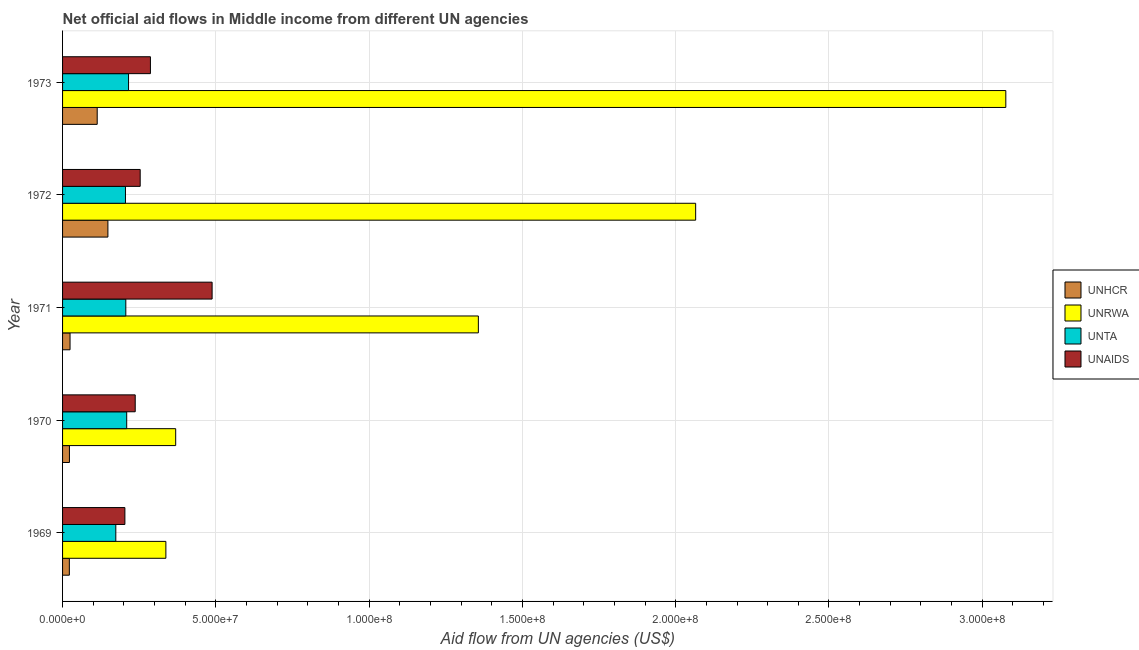How many different coloured bars are there?
Ensure brevity in your answer.  4. Are the number of bars per tick equal to the number of legend labels?
Make the answer very short. Yes. What is the label of the 5th group of bars from the top?
Provide a succinct answer. 1969. In how many cases, is the number of bars for a given year not equal to the number of legend labels?
Provide a succinct answer. 0. What is the amount of aid given by unta in 1969?
Provide a short and direct response. 1.74e+07. Across all years, what is the maximum amount of aid given by unta?
Your answer should be compact. 2.15e+07. Across all years, what is the minimum amount of aid given by unhcr?
Your answer should be compact. 2.21e+06. In which year was the amount of aid given by unaids maximum?
Ensure brevity in your answer.  1971. In which year was the amount of aid given by unrwa minimum?
Provide a short and direct response. 1969. What is the total amount of aid given by unrwa in the graph?
Provide a succinct answer. 7.20e+08. What is the difference between the amount of aid given by unhcr in 1970 and that in 1973?
Give a very brief answer. -9.06e+06. What is the difference between the amount of aid given by unaids in 1972 and the amount of aid given by unrwa in 1970?
Offer a terse response. -1.16e+07. What is the average amount of aid given by unta per year?
Offer a terse response. 2.02e+07. In the year 1971, what is the difference between the amount of aid given by unta and amount of aid given by unaids?
Give a very brief answer. -2.82e+07. What is the ratio of the amount of aid given by unhcr in 1970 to that in 1971?
Keep it short and to the point. 0.92. Is the difference between the amount of aid given by unaids in 1970 and 1971 greater than the difference between the amount of aid given by unta in 1970 and 1971?
Provide a short and direct response. No. What is the difference between the highest and the second highest amount of aid given by unrwa?
Give a very brief answer. 1.01e+08. What is the difference between the highest and the lowest amount of aid given by unta?
Your answer should be compact. 4.15e+06. In how many years, is the amount of aid given by unta greater than the average amount of aid given by unta taken over all years?
Provide a short and direct response. 4. Is it the case that in every year, the sum of the amount of aid given by unrwa and amount of aid given by unaids is greater than the sum of amount of aid given by unta and amount of aid given by unhcr?
Your answer should be compact. Yes. What does the 2nd bar from the top in 1969 represents?
Your response must be concise. UNTA. What does the 1st bar from the bottom in 1969 represents?
Provide a succinct answer. UNHCR. How many bars are there?
Keep it short and to the point. 20. How many years are there in the graph?
Your response must be concise. 5. Are the values on the major ticks of X-axis written in scientific E-notation?
Your answer should be compact. Yes. How many legend labels are there?
Offer a terse response. 4. How are the legend labels stacked?
Provide a short and direct response. Vertical. What is the title of the graph?
Offer a terse response. Net official aid flows in Middle income from different UN agencies. Does "Portugal" appear as one of the legend labels in the graph?
Provide a succinct answer. No. What is the label or title of the X-axis?
Provide a succinct answer. Aid flow from UN agencies (US$). What is the Aid flow from UN agencies (US$) of UNHCR in 1969?
Keep it short and to the point. 2.21e+06. What is the Aid flow from UN agencies (US$) of UNRWA in 1969?
Ensure brevity in your answer.  3.37e+07. What is the Aid flow from UN agencies (US$) of UNTA in 1969?
Offer a very short reply. 1.74e+07. What is the Aid flow from UN agencies (US$) of UNAIDS in 1969?
Your answer should be compact. 2.03e+07. What is the Aid flow from UN agencies (US$) of UNHCR in 1970?
Offer a very short reply. 2.24e+06. What is the Aid flow from UN agencies (US$) in UNRWA in 1970?
Your answer should be compact. 3.69e+07. What is the Aid flow from UN agencies (US$) in UNTA in 1970?
Make the answer very short. 2.09e+07. What is the Aid flow from UN agencies (US$) in UNAIDS in 1970?
Give a very brief answer. 2.37e+07. What is the Aid flow from UN agencies (US$) in UNHCR in 1971?
Offer a very short reply. 2.44e+06. What is the Aid flow from UN agencies (US$) in UNRWA in 1971?
Keep it short and to the point. 1.36e+08. What is the Aid flow from UN agencies (US$) of UNTA in 1971?
Offer a terse response. 2.06e+07. What is the Aid flow from UN agencies (US$) in UNAIDS in 1971?
Provide a succinct answer. 4.88e+07. What is the Aid flow from UN agencies (US$) in UNHCR in 1972?
Provide a short and direct response. 1.48e+07. What is the Aid flow from UN agencies (US$) in UNRWA in 1972?
Ensure brevity in your answer.  2.07e+08. What is the Aid flow from UN agencies (US$) of UNTA in 1972?
Provide a short and direct response. 2.05e+07. What is the Aid flow from UN agencies (US$) of UNAIDS in 1972?
Provide a succinct answer. 2.53e+07. What is the Aid flow from UN agencies (US$) in UNHCR in 1973?
Offer a very short reply. 1.13e+07. What is the Aid flow from UN agencies (US$) in UNRWA in 1973?
Provide a succinct answer. 3.08e+08. What is the Aid flow from UN agencies (US$) of UNTA in 1973?
Provide a short and direct response. 2.15e+07. What is the Aid flow from UN agencies (US$) of UNAIDS in 1973?
Make the answer very short. 2.87e+07. Across all years, what is the maximum Aid flow from UN agencies (US$) of UNHCR?
Offer a very short reply. 1.48e+07. Across all years, what is the maximum Aid flow from UN agencies (US$) in UNRWA?
Your answer should be compact. 3.08e+08. Across all years, what is the maximum Aid flow from UN agencies (US$) of UNTA?
Provide a succinct answer. 2.15e+07. Across all years, what is the maximum Aid flow from UN agencies (US$) of UNAIDS?
Offer a terse response. 4.88e+07. Across all years, what is the minimum Aid flow from UN agencies (US$) of UNHCR?
Your response must be concise. 2.21e+06. Across all years, what is the minimum Aid flow from UN agencies (US$) of UNRWA?
Offer a very short reply. 3.37e+07. Across all years, what is the minimum Aid flow from UN agencies (US$) in UNTA?
Provide a succinct answer. 1.74e+07. Across all years, what is the minimum Aid flow from UN agencies (US$) in UNAIDS?
Offer a terse response. 2.03e+07. What is the total Aid flow from UN agencies (US$) in UNHCR in the graph?
Offer a very short reply. 3.30e+07. What is the total Aid flow from UN agencies (US$) of UNRWA in the graph?
Keep it short and to the point. 7.20e+08. What is the total Aid flow from UN agencies (US$) in UNTA in the graph?
Your answer should be compact. 1.01e+08. What is the total Aid flow from UN agencies (US$) in UNAIDS in the graph?
Your response must be concise. 1.47e+08. What is the difference between the Aid flow from UN agencies (US$) of UNHCR in 1969 and that in 1970?
Make the answer very short. -3.00e+04. What is the difference between the Aid flow from UN agencies (US$) in UNRWA in 1969 and that in 1970?
Offer a very short reply. -3.20e+06. What is the difference between the Aid flow from UN agencies (US$) of UNTA in 1969 and that in 1970?
Your answer should be compact. -3.55e+06. What is the difference between the Aid flow from UN agencies (US$) in UNAIDS in 1969 and that in 1970?
Give a very brief answer. -3.37e+06. What is the difference between the Aid flow from UN agencies (US$) of UNRWA in 1969 and that in 1971?
Ensure brevity in your answer.  -1.02e+08. What is the difference between the Aid flow from UN agencies (US$) in UNTA in 1969 and that in 1971?
Offer a terse response. -3.26e+06. What is the difference between the Aid flow from UN agencies (US$) in UNAIDS in 1969 and that in 1971?
Give a very brief answer. -2.84e+07. What is the difference between the Aid flow from UN agencies (US$) of UNHCR in 1969 and that in 1972?
Ensure brevity in your answer.  -1.26e+07. What is the difference between the Aid flow from UN agencies (US$) in UNRWA in 1969 and that in 1972?
Your answer should be compact. -1.73e+08. What is the difference between the Aid flow from UN agencies (US$) in UNTA in 1969 and that in 1972?
Offer a very short reply. -3.15e+06. What is the difference between the Aid flow from UN agencies (US$) of UNAIDS in 1969 and that in 1972?
Your answer should be very brief. -4.99e+06. What is the difference between the Aid flow from UN agencies (US$) of UNHCR in 1969 and that in 1973?
Your answer should be compact. -9.09e+06. What is the difference between the Aid flow from UN agencies (US$) in UNRWA in 1969 and that in 1973?
Offer a terse response. -2.74e+08. What is the difference between the Aid flow from UN agencies (US$) of UNTA in 1969 and that in 1973?
Keep it short and to the point. -4.15e+06. What is the difference between the Aid flow from UN agencies (US$) of UNAIDS in 1969 and that in 1973?
Ensure brevity in your answer.  -8.33e+06. What is the difference between the Aid flow from UN agencies (US$) of UNHCR in 1970 and that in 1971?
Your answer should be very brief. -2.00e+05. What is the difference between the Aid flow from UN agencies (US$) of UNRWA in 1970 and that in 1971?
Offer a very short reply. -9.87e+07. What is the difference between the Aid flow from UN agencies (US$) of UNAIDS in 1970 and that in 1971?
Provide a succinct answer. -2.51e+07. What is the difference between the Aid flow from UN agencies (US$) of UNHCR in 1970 and that in 1972?
Your answer should be compact. -1.26e+07. What is the difference between the Aid flow from UN agencies (US$) of UNRWA in 1970 and that in 1972?
Keep it short and to the point. -1.70e+08. What is the difference between the Aid flow from UN agencies (US$) of UNTA in 1970 and that in 1972?
Offer a terse response. 4.00e+05. What is the difference between the Aid flow from UN agencies (US$) in UNAIDS in 1970 and that in 1972?
Make the answer very short. -1.62e+06. What is the difference between the Aid flow from UN agencies (US$) of UNHCR in 1970 and that in 1973?
Keep it short and to the point. -9.06e+06. What is the difference between the Aid flow from UN agencies (US$) in UNRWA in 1970 and that in 1973?
Provide a succinct answer. -2.71e+08. What is the difference between the Aid flow from UN agencies (US$) of UNTA in 1970 and that in 1973?
Your answer should be compact. -6.00e+05. What is the difference between the Aid flow from UN agencies (US$) of UNAIDS in 1970 and that in 1973?
Provide a succinct answer. -4.96e+06. What is the difference between the Aid flow from UN agencies (US$) in UNHCR in 1971 and that in 1972?
Your answer should be compact. -1.24e+07. What is the difference between the Aid flow from UN agencies (US$) of UNRWA in 1971 and that in 1972?
Give a very brief answer. -7.09e+07. What is the difference between the Aid flow from UN agencies (US$) of UNAIDS in 1971 and that in 1972?
Provide a succinct answer. 2.35e+07. What is the difference between the Aid flow from UN agencies (US$) of UNHCR in 1971 and that in 1973?
Provide a short and direct response. -8.86e+06. What is the difference between the Aid flow from UN agencies (US$) in UNRWA in 1971 and that in 1973?
Offer a very short reply. -1.72e+08. What is the difference between the Aid flow from UN agencies (US$) of UNTA in 1971 and that in 1973?
Your answer should be compact. -8.90e+05. What is the difference between the Aid flow from UN agencies (US$) in UNAIDS in 1971 and that in 1973?
Provide a short and direct response. 2.01e+07. What is the difference between the Aid flow from UN agencies (US$) of UNHCR in 1972 and that in 1973?
Give a very brief answer. 3.49e+06. What is the difference between the Aid flow from UN agencies (US$) of UNRWA in 1972 and that in 1973?
Provide a short and direct response. -1.01e+08. What is the difference between the Aid flow from UN agencies (US$) in UNTA in 1972 and that in 1973?
Offer a very short reply. -1.00e+06. What is the difference between the Aid flow from UN agencies (US$) in UNAIDS in 1972 and that in 1973?
Your response must be concise. -3.34e+06. What is the difference between the Aid flow from UN agencies (US$) of UNHCR in 1969 and the Aid flow from UN agencies (US$) of UNRWA in 1970?
Offer a terse response. -3.47e+07. What is the difference between the Aid flow from UN agencies (US$) of UNHCR in 1969 and the Aid flow from UN agencies (US$) of UNTA in 1970?
Your response must be concise. -1.87e+07. What is the difference between the Aid flow from UN agencies (US$) in UNHCR in 1969 and the Aid flow from UN agencies (US$) in UNAIDS in 1970?
Your answer should be compact. -2.15e+07. What is the difference between the Aid flow from UN agencies (US$) in UNRWA in 1969 and the Aid flow from UN agencies (US$) in UNTA in 1970?
Provide a short and direct response. 1.28e+07. What is the difference between the Aid flow from UN agencies (US$) in UNRWA in 1969 and the Aid flow from UN agencies (US$) in UNAIDS in 1970?
Your answer should be very brief. 1.00e+07. What is the difference between the Aid flow from UN agencies (US$) in UNTA in 1969 and the Aid flow from UN agencies (US$) in UNAIDS in 1970?
Your answer should be very brief. -6.33e+06. What is the difference between the Aid flow from UN agencies (US$) in UNHCR in 1969 and the Aid flow from UN agencies (US$) in UNRWA in 1971?
Give a very brief answer. -1.33e+08. What is the difference between the Aid flow from UN agencies (US$) in UNHCR in 1969 and the Aid flow from UN agencies (US$) in UNTA in 1971?
Offer a terse response. -1.84e+07. What is the difference between the Aid flow from UN agencies (US$) in UNHCR in 1969 and the Aid flow from UN agencies (US$) in UNAIDS in 1971?
Ensure brevity in your answer.  -4.66e+07. What is the difference between the Aid flow from UN agencies (US$) of UNRWA in 1969 and the Aid flow from UN agencies (US$) of UNTA in 1971?
Your answer should be very brief. 1.31e+07. What is the difference between the Aid flow from UN agencies (US$) of UNRWA in 1969 and the Aid flow from UN agencies (US$) of UNAIDS in 1971?
Offer a terse response. -1.51e+07. What is the difference between the Aid flow from UN agencies (US$) in UNTA in 1969 and the Aid flow from UN agencies (US$) in UNAIDS in 1971?
Offer a very short reply. -3.14e+07. What is the difference between the Aid flow from UN agencies (US$) of UNHCR in 1969 and the Aid flow from UN agencies (US$) of UNRWA in 1972?
Your answer should be compact. -2.04e+08. What is the difference between the Aid flow from UN agencies (US$) of UNHCR in 1969 and the Aid flow from UN agencies (US$) of UNTA in 1972?
Ensure brevity in your answer.  -1.83e+07. What is the difference between the Aid flow from UN agencies (US$) in UNHCR in 1969 and the Aid flow from UN agencies (US$) in UNAIDS in 1972?
Keep it short and to the point. -2.31e+07. What is the difference between the Aid flow from UN agencies (US$) of UNRWA in 1969 and the Aid flow from UN agencies (US$) of UNTA in 1972?
Make the answer very short. 1.32e+07. What is the difference between the Aid flow from UN agencies (US$) of UNRWA in 1969 and the Aid flow from UN agencies (US$) of UNAIDS in 1972?
Your answer should be compact. 8.38e+06. What is the difference between the Aid flow from UN agencies (US$) of UNTA in 1969 and the Aid flow from UN agencies (US$) of UNAIDS in 1972?
Your response must be concise. -7.95e+06. What is the difference between the Aid flow from UN agencies (US$) of UNHCR in 1969 and the Aid flow from UN agencies (US$) of UNRWA in 1973?
Keep it short and to the point. -3.05e+08. What is the difference between the Aid flow from UN agencies (US$) of UNHCR in 1969 and the Aid flow from UN agencies (US$) of UNTA in 1973?
Give a very brief answer. -1.93e+07. What is the difference between the Aid flow from UN agencies (US$) in UNHCR in 1969 and the Aid flow from UN agencies (US$) in UNAIDS in 1973?
Your answer should be compact. -2.64e+07. What is the difference between the Aid flow from UN agencies (US$) in UNRWA in 1969 and the Aid flow from UN agencies (US$) in UNTA in 1973?
Offer a very short reply. 1.22e+07. What is the difference between the Aid flow from UN agencies (US$) in UNRWA in 1969 and the Aid flow from UN agencies (US$) in UNAIDS in 1973?
Keep it short and to the point. 5.04e+06. What is the difference between the Aid flow from UN agencies (US$) of UNTA in 1969 and the Aid flow from UN agencies (US$) of UNAIDS in 1973?
Give a very brief answer. -1.13e+07. What is the difference between the Aid flow from UN agencies (US$) of UNHCR in 1970 and the Aid flow from UN agencies (US$) of UNRWA in 1971?
Ensure brevity in your answer.  -1.33e+08. What is the difference between the Aid flow from UN agencies (US$) of UNHCR in 1970 and the Aid flow from UN agencies (US$) of UNTA in 1971?
Your response must be concise. -1.84e+07. What is the difference between the Aid flow from UN agencies (US$) of UNHCR in 1970 and the Aid flow from UN agencies (US$) of UNAIDS in 1971?
Make the answer very short. -4.65e+07. What is the difference between the Aid flow from UN agencies (US$) in UNRWA in 1970 and the Aid flow from UN agencies (US$) in UNTA in 1971?
Make the answer very short. 1.63e+07. What is the difference between the Aid flow from UN agencies (US$) in UNRWA in 1970 and the Aid flow from UN agencies (US$) in UNAIDS in 1971?
Offer a very short reply. -1.19e+07. What is the difference between the Aid flow from UN agencies (US$) of UNTA in 1970 and the Aid flow from UN agencies (US$) of UNAIDS in 1971?
Provide a succinct answer. -2.79e+07. What is the difference between the Aid flow from UN agencies (US$) of UNHCR in 1970 and the Aid flow from UN agencies (US$) of UNRWA in 1972?
Offer a terse response. -2.04e+08. What is the difference between the Aid flow from UN agencies (US$) of UNHCR in 1970 and the Aid flow from UN agencies (US$) of UNTA in 1972?
Your response must be concise. -1.83e+07. What is the difference between the Aid flow from UN agencies (US$) in UNHCR in 1970 and the Aid flow from UN agencies (US$) in UNAIDS in 1972?
Offer a terse response. -2.31e+07. What is the difference between the Aid flow from UN agencies (US$) in UNRWA in 1970 and the Aid flow from UN agencies (US$) in UNTA in 1972?
Give a very brief answer. 1.64e+07. What is the difference between the Aid flow from UN agencies (US$) of UNRWA in 1970 and the Aid flow from UN agencies (US$) of UNAIDS in 1972?
Your answer should be compact. 1.16e+07. What is the difference between the Aid flow from UN agencies (US$) in UNTA in 1970 and the Aid flow from UN agencies (US$) in UNAIDS in 1972?
Your response must be concise. -4.40e+06. What is the difference between the Aid flow from UN agencies (US$) of UNHCR in 1970 and the Aid flow from UN agencies (US$) of UNRWA in 1973?
Your answer should be very brief. -3.05e+08. What is the difference between the Aid flow from UN agencies (US$) in UNHCR in 1970 and the Aid flow from UN agencies (US$) in UNTA in 1973?
Your response must be concise. -1.93e+07. What is the difference between the Aid flow from UN agencies (US$) in UNHCR in 1970 and the Aid flow from UN agencies (US$) in UNAIDS in 1973?
Offer a terse response. -2.64e+07. What is the difference between the Aid flow from UN agencies (US$) in UNRWA in 1970 and the Aid flow from UN agencies (US$) in UNTA in 1973?
Offer a terse response. 1.54e+07. What is the difference between the Aid flow from UN agencies (US$) of UNRWA in 1970 and the Aid flow from UN agencies (US$) of UNAIDS in 1973?
Give a very brief answer. 8.24e+06. What is the difference between the Aid flow from UN agencies (US$) of UNTA in 1970 and the Aid flow from UN agencies (US$) of UNAIDS in 1973?
Your answer should be compact. -7.74e+06. What is the difference between the Aid flow from UN agencies (US$) in UNHCR in 1971 and the Aid flow from UN agencies (US$) in UNRWA in 1972?
Your answer should be very brief. -2.04e+08. What is the difference between the Aid flow from UN agencies (US$) in UNHCR in 1971 and the Aid flow from UN agencies (US$) in UNTA in 1972?
Provide a succinct answer. -1.81e+07. What is the difference between the Aid flow from UN agencies (US$) in UNHCR in 1971 and the Aid flow from UN agencies (US$) in UNAIDS in 1972?
Provide a short and direct response. -2.29e+07. What is the difference between the Aid flow from UN agencies (US$) in UNRWA in 1971 and the Aid flow from UN agencies (US$) in UNTA in 1972?
Ensure brevity in your answer.  1.15e+08. What is the difference between the Aid flow from UN agencies (US$) in UNRWA in 1971 and the Aid flow from UN agencies (US$) in UNAIDS in 1972?
Give a very brief answer. 1.10e+08. What is the difference between the Aid flow from UN agencies (US$) in UNTA in 1971 and the Aid flow from UN agencies (US$) in UNAIDS in 1972?
Make the answer very short. -4.69e+06. What is the difference between the Aid flow from UN agencies (US$) in UNHCR in 1971 and the Aid flow from UN agencies (US$) in UNRWA in 1973?
Your answer should be compact. -3.05e+08. What is the difference between the Aid flow from UN agencies (US$) of UNHCR in 1971 and the Aid flow from UN agencies (US$) of UNTA in 1973?
Make the answer very short. -1.91e+07. What is the difference between the Aid flow from UN agencies (US$) in UNHCR in 1971 and the Aid flow from UN agencies (US$) in UNAIDS in 1973?
Provide a short and direct response. -2.62e+07. What is the difference between the Aid flow from UN agencies (US$) in UNRWA in 1971 and the Aid flow from UN agencies (US$) in UNTA in 1973?
Offer a terse response. 1.14e+08. What is the difference between the Aid flow from UN agencies (US$) of UNRWA in 1971 and the Aid flow from UN agencies (US$) of UNAIDS in 1973?
Keep it short and to the point. 1.07e+08. What is the difference between the Aid flow from UN agencies (US$) of UNTA in 1971 and the Aid flow from UN agencies (US$) of UNAIDS in 1973?
Ensure brevity in your answer.  -8.03e+06. What is the difference between the Aid flow from UN agencies (US$) in UNHCR in 1972 and the Aid flow from UN agencies (US$) in UNRWA in 1973?
Offer a very short reply. -2.93e+08. What is the difference between the Aid flow from UN agencies (US$) of UNHCR in 1972 and the Aid flow from UN agencies (US$) of UNTA in 1973?
Your answer should be very brief. -6.73e+06. What is the difference between the Aid flow from UN agencies (US$) of UNHCR in 1972 and the Aid flow from UN agencies (US$) of UNAIDS in 1973?
Give a very brief answer. -1.39e+07. What is the difference between the Aid flow from UN agencies (US$) of UNRWA in 1972 and the Aid flow from UN agencies (US$) of UNTA in 1973?
Keep it short and to the point. 1.85e+08. What is the difference between the Aid flow from UN agencies (US$) in UNRWA in 1972 and the Aid flow from UN agencies (US$) in UNAIDS in 1973?
Ensure brevity in your answer.  1.78e+08. What is the difference between the Aid flow from UN agencies (US$) of UNTA in 1972 and the Aid flow from UN agencies (US$) of UNAIDS in 1973?
Give a very brief answer. -8.14e+06. What is the average Aid flow from UN agencies (US$) in UNHCR per year?
Keep it short and to the point. 6.60e+06. What is the average Aid flow from UN agencies (US$) in UNRWA per year?
Make the answer very short. 1.44e+08. What is the average Aid flow from UN agencies (US$) of UNTA per year?
Make the answer very short. 2.02e+07. What is the average Aid flow from UN agencies (US$) of UNAIDS per year?
Provide a succinct answer. 2.94e+07. In the year 1969, what is the difference between the Aid flow from UN agencies (US$) in UNHCR and Aid flow from UN agencies (US$) in UNRWA?
Offer a very short reply. -3.15e+07. In the year 1969, what is the difference between the Aid flow from UN agencies (US$) in UNHCR and Aid flow from UN agencies (US$) in UNTA?
Offer a very short reply. -1.52e+07. In the year 1969, what is the difference between the Aid flow from UN agencies (US$) of UNHCR and Aid flow from UN agencies (US$) of UNAIDS?
Ensure brevity in your answer.  -1.81e+07. In the year 1969, what is the difference between the Aid flow from UN agencies (US$) of UNRWA and Aid flow from UN agencies (US$) of UNTA?
Ensure brevity in your answer.  1.63e+07. In the year 1969, what is the difference between the Aid flow from UN agencies (US$) in UNRWA and Aid flow from UN agencies (US$) in UNAIDS?
Your answer should be compact. 1.34e+07. In the year 1969, what is the difference between the Aid flow from UN agencies (US$) of UNTA and Aid flow from UN agencies (US$) of UNAIDS?
Your response must be concise. -2.96e+06. In the year 1970, what is the difference between the Aid flow from UN agencies (US$) of UNHCR and Aid flow from UN agencies (US$) of UNRWA?
Make the answer very short. -3.47e+07. In the year 1970, what is the difference between the Aid flow from UN agencies (US$) of UNHCR and Aid flow from UN agencies (US$) of UNTA?
Keep it short and to the point. -1.87e+07. In the year 1970, what is the difference between the Aid flow from UN agencies (US$) in UNHCR and Aid flow from UN agencies (US$) in UNAIDS?
Your answer should be very brief. -2.15e+07. In the year 1970, what is the difference between the Aid flow from UN agencies (US$) in UNRWA and Aid flow from UN agencies (US$) in UNTA?
Provide a succinct answer. 1.60e+07. In the year 1970, what is the difference between the Aid flow from UN agencies (US$) in UNRWA and Aid flow from UN agencies (US$) in UNAIDS?
Your answer should be very brief. 1.32e+07. In the year 1970, what is the difference between the Aid flow from UN agencies (US$) in UNTA and Aid flow from UN agencies (US$) in UNAIDS?
Offer a terse response. -2.78e+06. In the year 1971, what is the difference between the Aid flow from UN agencies (US$) of UNHCR and Aid flow from UN agencies (US$) of UNRWA?
Ensure brevity in your answer.  -1.33e+08. In the year 1971, what is the difference between the Aid flow from UN agencies (US$) of UNHCR and Aid flow from UN agencies (US$) of UNTA?
Give a very brief answer. -1.82e+07. In the year 1971, what is the difference between the Aid flow from UN agencies (US$) in UNHCR and Aid flow from UN agencies (US$) in UNAIDS?
Ensure brevity in your answer.  -4.63e+07. In the year 1971, what is the difference between the Aid flow from UN agencies (US$) of UNRWA and Aid flow from UN agencies (US$) of UNTA?
Your answer should be compact. 1.15e+08. In the year 1971, what is the difference between the Aid flow from UN agencies (US$) of UNRWA and Aid flow from UN agencies (US$) of UNAIDS?
Offer a terse response. 8.68e+07. In the year 1971, what is the difference between the Aid flow from UN agencies (US$) in UNTA and Aid flow from UN agencies (US$) in UNAIDS?
Offer a terse response. -2.82e+07. In the year 1972, what is the difference between the Aid flow from UN agencies (US$) in UNHCR and Aid flow from UN agencies (US$) in UNRWA?
Ensure brevity in your answer.  -1.92e+08. In the year 1972, what is the difference between the Aid flow from UN agencies (US$) in UNHCR and Aid flow from UN agencies (US$) in UNTA?
Your answer should be compact. -5.73e+06. In the year 1972, what is the difference between the Aid flow from UN agencies (US$) of UNHCR and Aid flow from UN agencies (US$) of UNAIDS?
Provide a succinct answer. -1.05e+07. In the year 1972, what is the difference between the Aid flow from UN agencies (US$) of UNRWA and Aid flow from UN agencies (US$) of UNTA?
Provide a succinct answer. 1.86e+08. In the year 1972, what is the difference between the Aid flow from UN agencies (US$) of UNRWA and Aid flow from UN agencies (US$) of UNAIDS?
Give a very brief answer. 1.81e+08. In the year 1972, what is the difference between the Aid flow from UN agencies (US$) in UNTA and Aid flow from UN agencies (US$) in UNAIDS?
Offer a very short reply. -4.80e+06. In the year 1973, what is the difference between the Aid flow from UN agencies (US$) of UNHCR and Aid flow from UN agencies (US$) of UNRWA?
Your answer should be compact. -2.96e+08. In the year 1973, what is the difference between the Aid flow from UN agencies (US$) in UNHCR and Aid flow from UN agencies (US$) in UNTA?
Give a very brief answer. -1.02e+07. In the year 1973, what is the difference between the Aid flow from UN agencies (US$) of UNHCR and Aid flow from UN agencies (US$) of UNAIDS?
Your answer should be very brief. -1.74e+07. In the year 1973, what is the difference between the Aid flow from UN agencies (US$) in UNRWA and Aid flow from UN agencies (US$) in UNTA?
Your response must be concise. 2.86e+08. In the year 1973, what is the difference between the Aid flow from UN agencies (US$) of UNRWA and Aid flow from UN agencies (US$) of UNAIDS?
Offer a terse response. 2.79e+08. In the year 1973, what is the difference between the Aid flow from UN agencies (US$) in UNTA and Aid flow from UN agencies (US$) in UNAIDS?
Give a very brief answer. -7.14e+06. What is the ratio of the Aid flow from UN agencies (US$) in UNHCR in 1969 to that in 1970?
Your answer should be compact. 0.99. What is the ratio of the Aid flow from UN agencies (US$) in UNRWA in 1969 to that in 1970?
Give a very brief answer. 0.91. What is the ratio of the Aid flow from UN agencies (US$) of UNTA in 1969 to that in 1970?
Ensure brevity in your answer.  0.83. What is the ratio of the Aid flow from UN agencies (US$) in UNAIDS in 1969 to that in 1970?
Provide a succinct answer. 0.86. What is the ratio of the Aid flow from UN agencies (US$) in UNHCR in 1969 to that in 1971?
Give a very brief answer. 0.91. What is the ratio of the Aid flow from UN agencies (US$) in UNRWA in 1969 to that in 1971?
Your answer should be very brief. 0.25. What is the ratio of the Aid flow from UN agencies (US$) in UNTA in 1969 to that in 1971?
Your answer should be compact. 0.84. What is the ratio of the Aid flow from UN agencies (US$) in UNAIDS in 1969 to that in 1971?
Your answer should be compact. 0.42. What is the ratio of the Aid flow from UN agencies (US$) of UNHCR in 1969 to that in 1972?
Provide a succinct answer. 0.15. What is the ratio of the Aid flow from UN agencies (US$) in UNRWA in 1969 to that in 1972?
Offer a terse response. 0.16. What is the ratio of the Aid flow from UN agencies (US$) in UNTA in 1969 to that in 1972?
Your answer should be compact. 0.85. What is the ratio of the Aid flow from UN agencies (US$) in UNAIDS in 1969 to that in 1972?
Offer a very short reply. 0.8. What is the ratio of the Aid flow from UN agencies (US$) of UNHCR in 1969 to that in 1973?
Make the answer very short. 0.2. What is the ratio of the Aid flow from UN agencies (US$) in UNRWA in 1969 to that in 1973?
Provide a succinct answer. 0.11. What is the ratio of the Aid flow from UN agencies (US$) in UNTA in 1969 to that in 1973?
Provide a short and direct response. 0.81. What is the ratio of the Aid flow from UN agencies (US$) in UNAIDS in 1969 to that in 1973?
Your response must be concise. 0.71. What is the ratio of the Aid flow from UN agencies (US$) in UNHCR in 1970 to that in 1971?
Offer a very short reply. 0.92. What is the ratio of the Aid flow from UN agencies (US$) of UNRWA in 1970 to that in 1971?
Your answer should be compact. 0.27. What is the ratio of the Aid flow from UN agencies (US$) in UNTA in 1970 to that in 1971?
Provide a short and direct response. 1.01. What is the ratio of the Aid flow from UN agencies (US$) in UNAIDS in 1970 to that in 1971?
Your response must be concise. 0.49. What is the ratio of the Aid flow from UN agencies (US$) in UNHCR in 1970 to that in 1972?
Offer a very short reply. 0.15. What is the ratio of the Aid flow from UN agencies (US$) in UNRWA in 1970 to that in 1972?
Your response must be concise. 0.18. What is the ratio of the Aid flow from UN agencies (US$) in UNTA in 1970 to that in 1972?
Provide a short and direct response. 1.02. What is the ratio of the Aid flow from UN agencies (US$) in UNAIDS in 1970 to that in 1972?
Give a very brief answer. 0.94. What is the ratio of the Aid flow from UN agencies (US$) in UNHCR in 1970 to that in 1973?
Your response must be concise. 0.2. What is the ratio of the Aid flow from UN agencies (US$) in UNRWA in 1970 to that in 1973?
Provide a succinct answer. 0.12. What is the ratio of the Aid flow from UN agencies (US$) in UNTA in 1970 to that in 1973?
Provide a succinct answer. 0.97. What is the ratio of the Aid flow from UN agencies (US$) of UNAIDS in 1970 to that in 1973?
Make the answer very short. 0.83. What is the ratio of the Aid flow from UN agencies (US$) of UNHCR in 1971 to that in 1972?
Give a very brief answer. 0.17. What is the ratio of the Aid flow from UN agencies (US$) of UNRWA in 1971 to that in 1972?
Offer a very short reply. 0.66. What is the ratio of the Aid flow from UN agencies (US$) of UNTA in 1971 to that in 1972?
Your answer should be very brief. 1.01. What is the ratio of the Aid flow from UN agencies (US$) of UNAIDS in 1971 to that in 1972?
Give a very brief answer. 1.93. What is the ratio of the Aid flow from UN agencies (US$) in UNHCR in 1971 to that in 1973?
Provide a short and direct response. 0.22. What is the ratio of the Aid flow from UN agencies (US$) in UNRWA in 1971 to that in 1973?
Offer a terse response. 0.44. What is the ratio of the Aid flow from UN agencies (US$) of UNTA in 1971 to that in 1973?
Provide a succinct answer. 0.96. What is the ratio of the Aid flow from UN agencies (US$) in UNAIDS in 1971 to that in 1973?
Your answer should be very brief. 1.7. What is the ratio of the Aid flow from UN agencies (US$) in UNHCR in 1972 to that in 1973?
Provide a succinct answer. 1.31. What is the ratio of the Aid flow from UN agencies (US$) of UNRWA in 1972 to that in 1973?
Offer a terse response. 0.67. What is the ratio of the Aid flow from UN agencies (US$) of UNTA in 1972 to that in 1973?
Offer a terse response. 0.95. What is the ratio of the Aid flow from UN agencies (US$) in UNAIDS in 1972 to that in 1973?
Offer a terse response. 0.88. What is the difference between the highest and the second highest Aid flow from UN agencies (US$) in UNHCR?
Give a very brief answer. 3.49e+06. What is the difference between the highest and the second highest Aid flow from UN agencies (US$) of UNRWA?
Your answer should be very brief. 1.01e+08. What is the difference between the highest and the second highest Aid flow from UN agencies (US$) of UNAIDS?
Ensure brevity in your answer.  2.01e+07. What is the difference between the highest and the lowest Aid flow from UN agencies (US$) of UNHCR?
Provide a short and direct response. 1.26e+07. What is the difference between the highest and the lowest Aid flow from UN agencies (US$) of UNRWA?
Make the answer very short. 2.74e+08. What is the difference between the highest and the lowest Aid flow from UN agencies (US$) in UNTA?
Your response must be concise. 4.15e+06. What is the difference between the highest and the lowest Aid flow from UN agencies (US$) in UNAIDS?
Your response must be concise. 2.84e+07. 